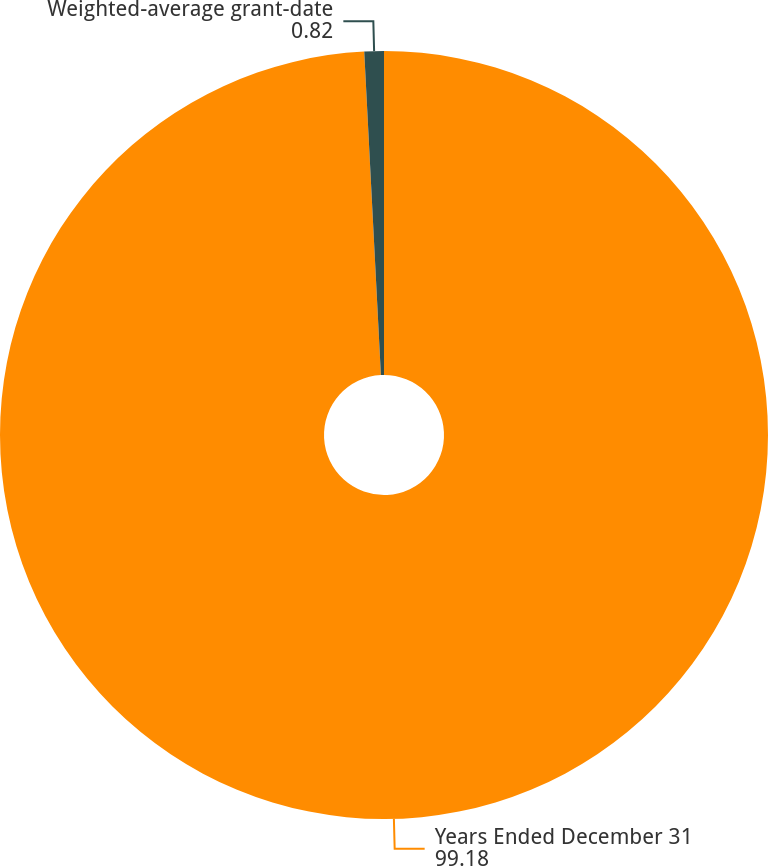Convert chart to OTSL. <chart><loc_0><loc_0><loc_500><loc_500><pie_chart><fcel>Years Ended December 31<fcel>Weighted-average grant-date<nl><fcel>99.18%<fcel>0.82%<nl></chart> 